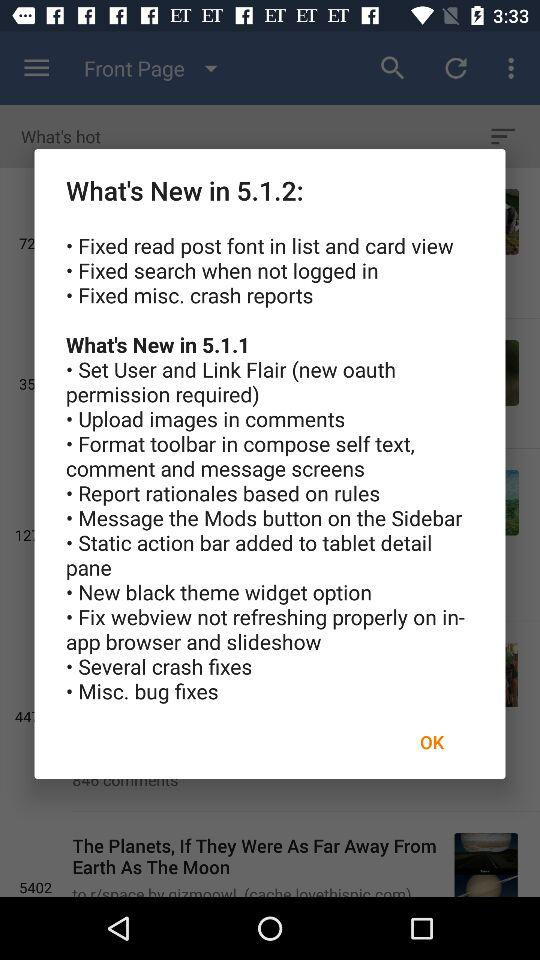When was "The Planets, If They Were As Far Away From Earth As The Moon" posted?
When the provided information is insufficient, respond with <no answer>. <no answer> 